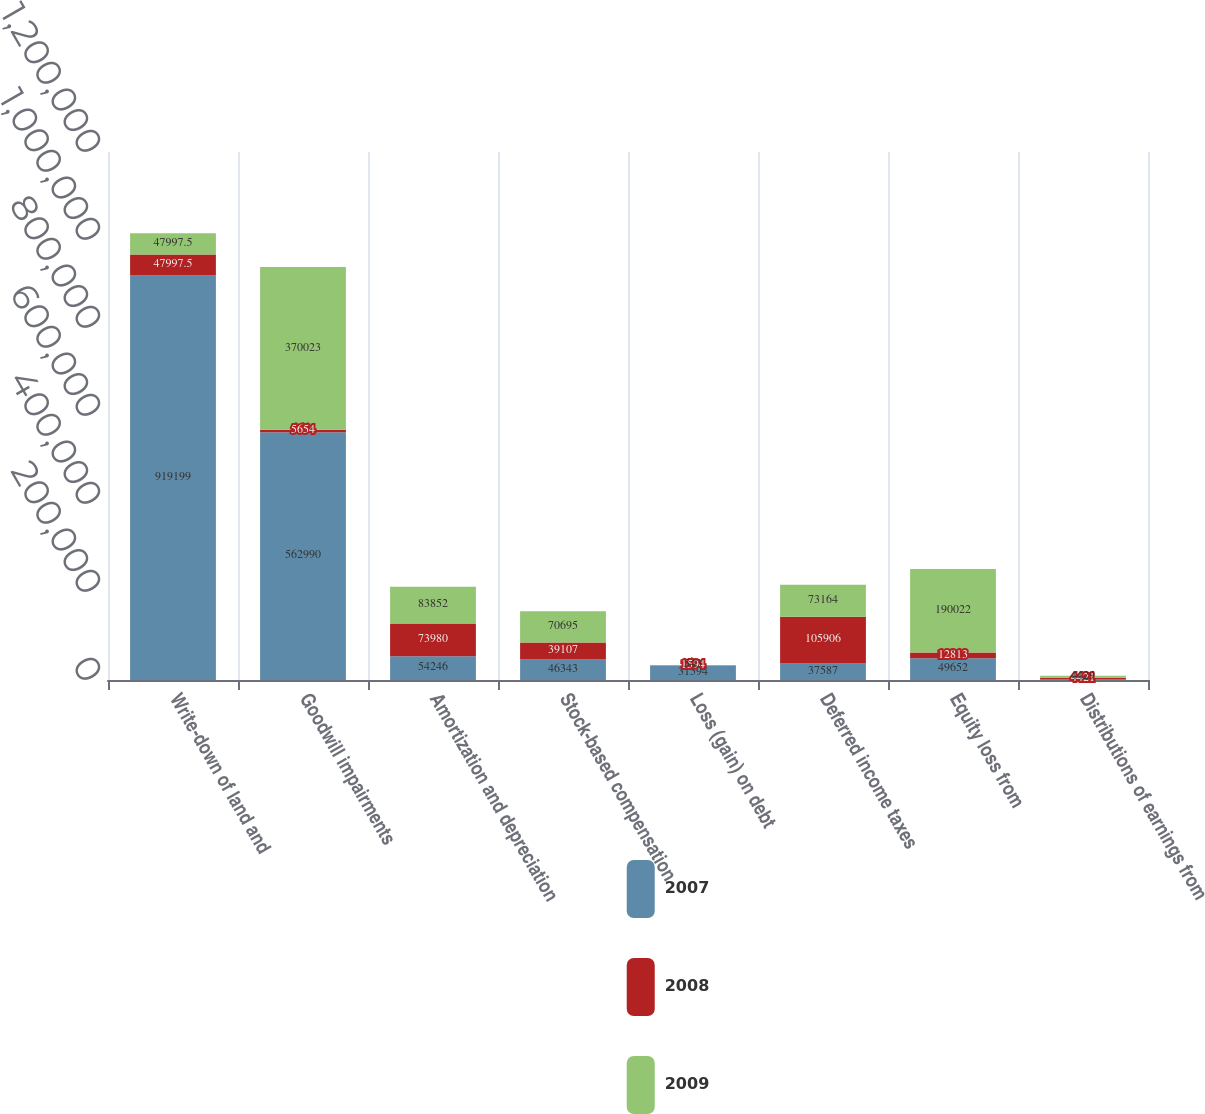<chart> <loc_0><loc_0><loc_500><loc_500><stacked_bar_chart><ecel><fcel>Write-down of land and<fcel>Goodwill impairments<fcel>Amortization and depreciation<fcel>Stock-based compensation<fcel>Loss (gain) on debt<fcel>Deferred income taxes<fcel>Equity loss from<fcel>Distributions of earnings from<nl><fcel>2007<fcel>919199<fcel>562990<fcel>54246<fcel>46343<fcel>31594<fcel>37587<fcel>49652<fcel>911<nl><fcel>2008<fcel>47997.5<fcel>5654<fcel>73980<fcel>39107<fcel>1594<fcel>105906<fcel>12813<fcel>4421<nl><fcel>2009<fcel>47997.5<fcel>370023<fcel>83852<fcel>70695<fcel>543<fcel>73164<fcel>190022<fcel>4429<nl></chart> 